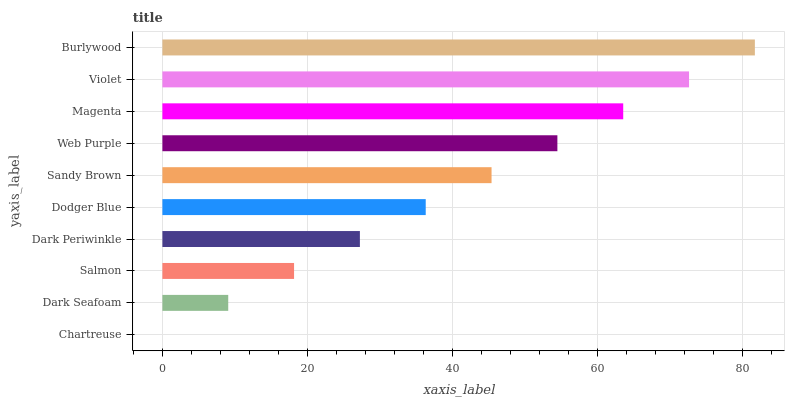Is Chartreuse the minimum?
Answer yes or no. Yes. Is Burlywood the maximum?
Answer yes or no. Yes. Is Dark Seafoam the minimum?
Answer yes or no. No. Is Dark Seafoam the maximum?
Answer yes or no. No. Is Dark Seafoam greater than Chartreuse?
Answer yes or no. Yes. Is Chartreuse less than Dark Seafoam?
Answer yes or no. Yes. Is Chartreuse greater than Dark Seafoam?
Answer yes or no. No. Is Dark Seafoam less than Chartreuse?
Answer yes or no. No. Is Sandy Brown the high median?
Answer yes or no. Yes. Is Dodger Blue the low median?
Answer yes or no. Yes. Is Magenta the high median?
Answer yes or no. No. Is Magenta the low median?
Answer yes or no. No. 